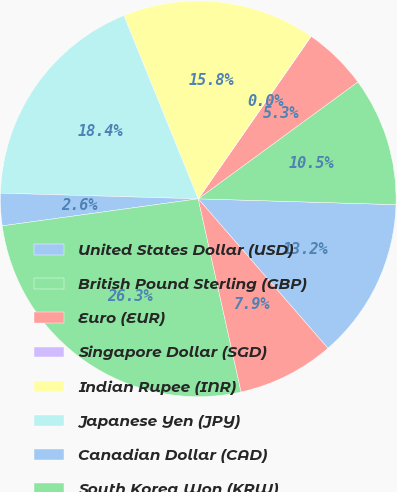<chart> <loc_0><loc_0><loc_500><loc_500><pie_chart><fcel>United States Dollar (USD)<fcel>British Pound Sterling (GBP)<fcel>Euro (EUR)<fcel>Singapore Dollar (SGD)<fcel>Indian Rupee (INR)<fcel>Japanese Yen (JPY)<fcel>Canadian Dollar (CAD)<fcel>South Korea Won (KRW)<fcel>Chinese Renmimbi (CNY)<nl><fcel>13.15%<fcel>10.53%<fcel>5.27%<fcel>0.02%<fcel>15.78%<fcel>18.41%<fcel>2.64%<fcel>26.29%<fcel>7.9%<nl></chart> 